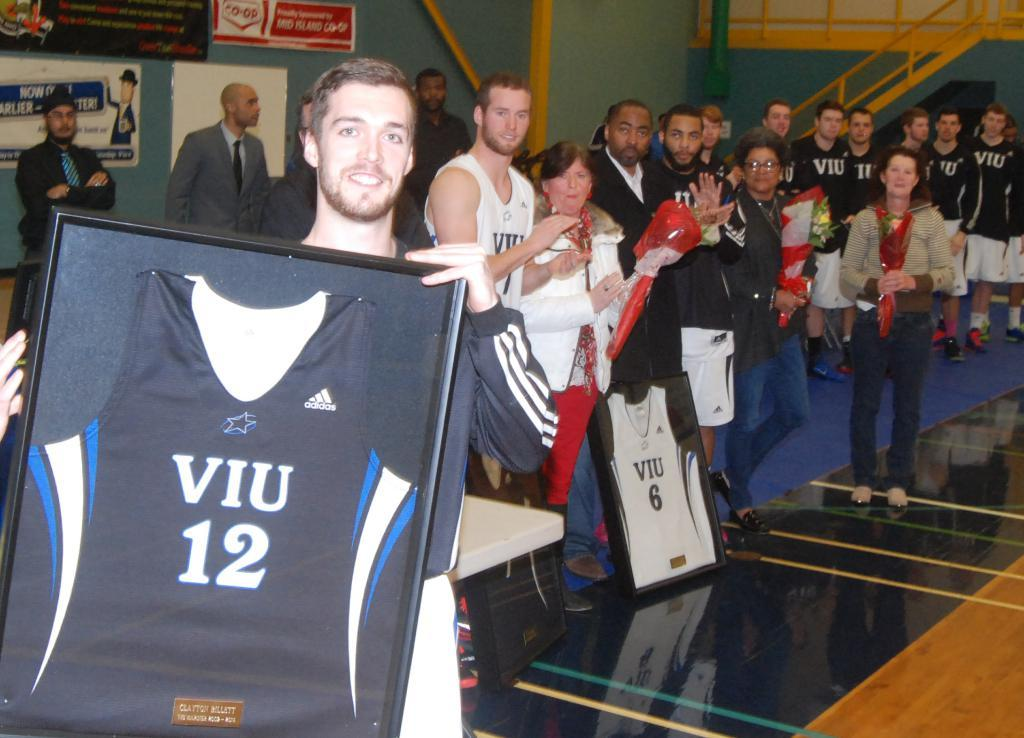<image>
Share a concise interpretation of the image provided. A man holding a picture of a shirt with Viu 12 written on it. 